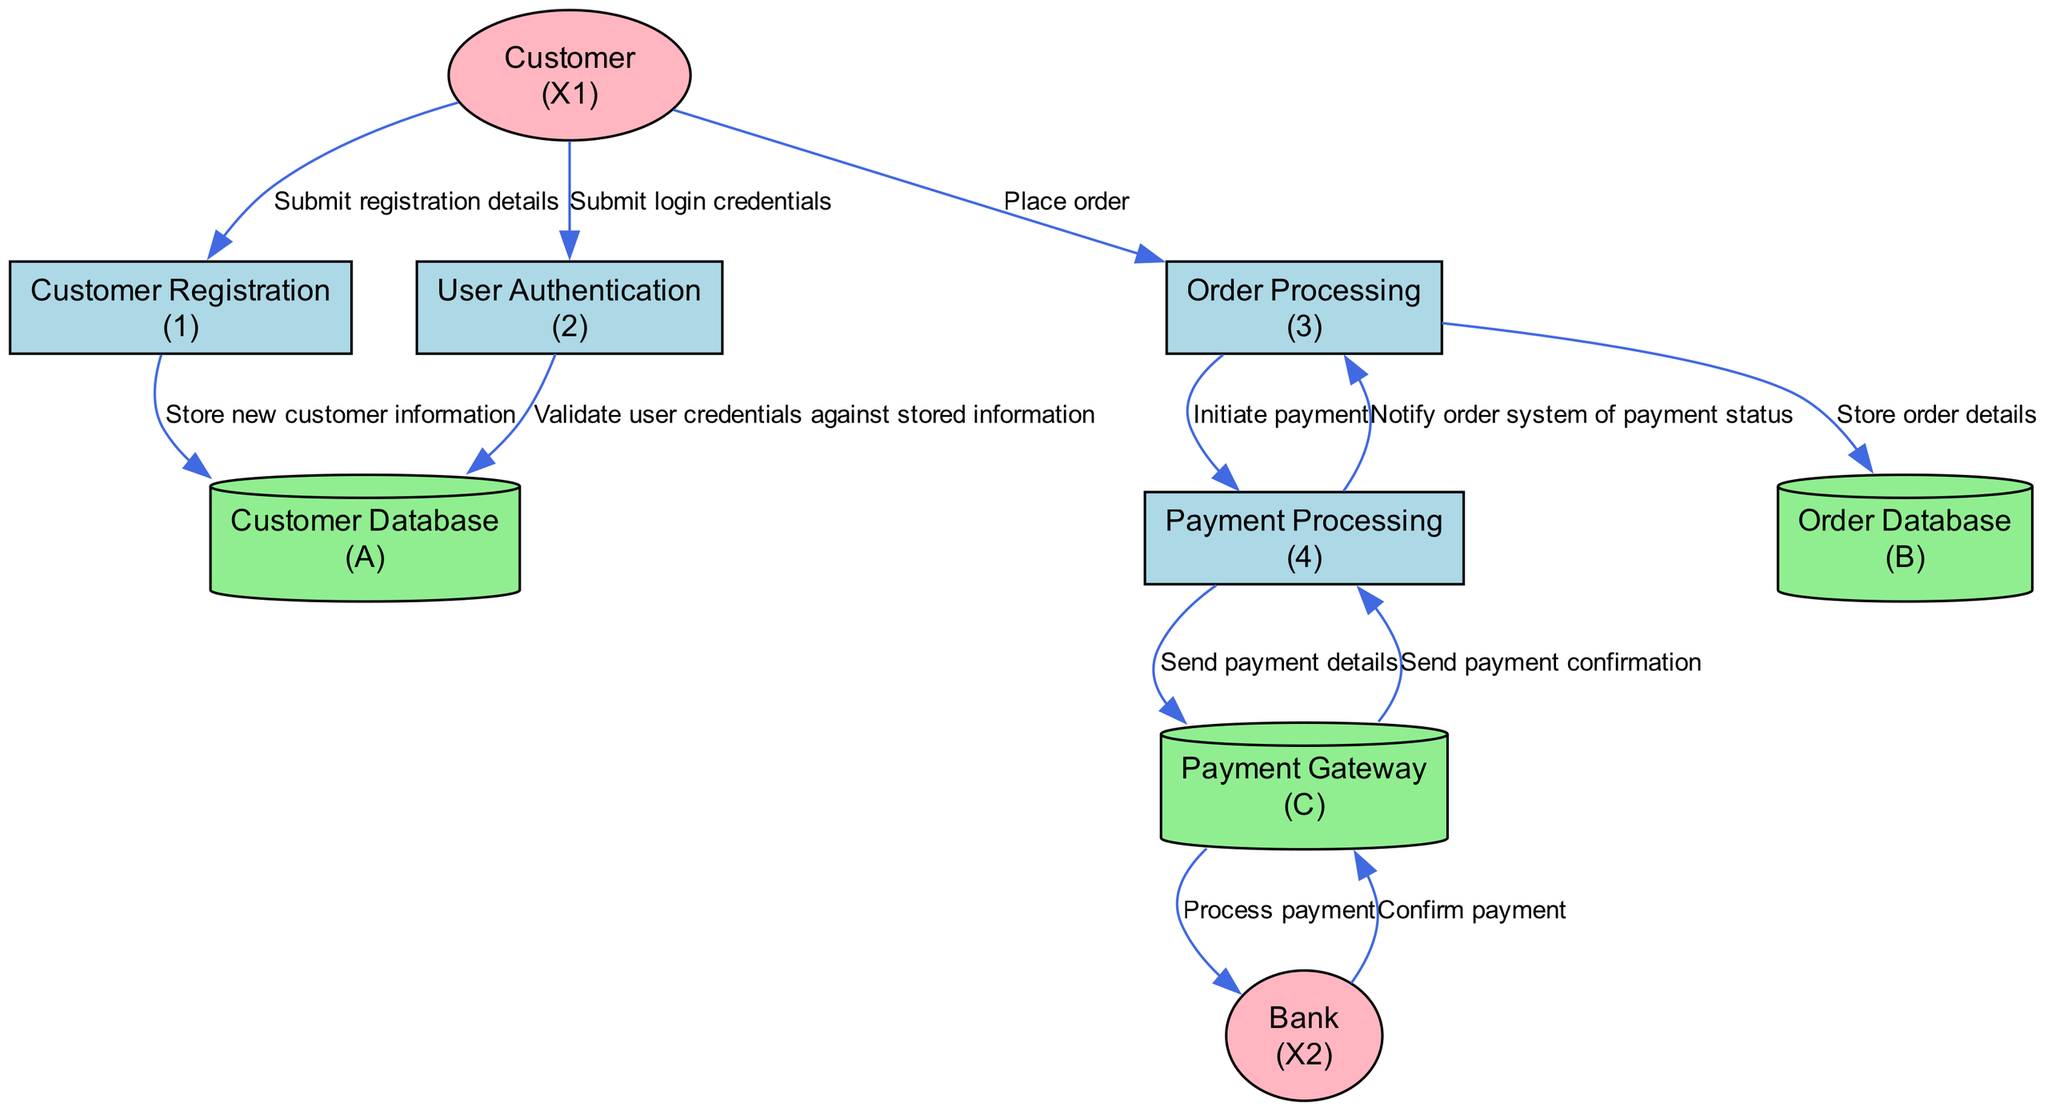What is the first process in the diagram? The first process is identified by the lowest process ID which corresponds to "Customer Registration". This process handles new customer sign-ups.
Answer: Customer Registration How many external entities are represented in the diagram? The diagram shows two external entities: "Customer" and "Bank". These represent the users and the payment processor respectively.
Answer: 2 What data store is utilized for storing order details? The data store designated for order details is labeled as "Order Database". It is explicitly mentioned in the context of order processing.
Answer: Order Database Which process handles payment transactions? The process responsible for payment transactions is "Payment Processing". It specifically manages the handling and confirmation of payments.
Answer: Payment Processing Which two processes are directly linked by one data flow? The "Order Processing" and "Payment Processing" processes are directly linked by the data flow that describes the initiation of payment. This indicates that order processing triggers the payment procedure.
Answer: Order Processing and Payment Processing How does the user authenticate themselves in this system? The user authenticates by submitting their login credentials to the "User Authentication" process, which verifies these credentials against stored information in the "Customer Database".
Answer: By submitting login credentials What is the final confirmation flow in the payment process from the bank? The final confirmation flow includes the "Bank" sending a confirmation back to the "Payment Gateway", which is a key part of the payment processing workflow. This confirms that the payment has been successfully processed.
Answer: Bank to Payment Gateway How many data flows originate from the "Order Processing" process? Three data flows originate from the "Order Processing" process: one stores order details, another initiates payment, and the last notifies the payment status.
Answer: 3 Which external entity is involved in processing the payment? The external entity involved in processing the payment is the "Bank". It serves as the financial institution that completes payment transactions initiated by the "Payment Gateway".
Answer: Bank What is the purpose of the "Customer Database"? The "Customer Database" serves to store customer information, which is crucial both for registration and for authentication purposes during user login.
Answer: Store customer information 